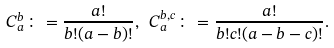<formula> <loc_0><loc_0><loc_500><loc_500>C _ { a } ^ { b } \colon = \frac { a ! } { b ! ( a - b ) ! } , \ C _ { a } ^ { b , c } \colon = \frac { a ! } { b ! c ! ( a - b - c ) ! } .</formula> 